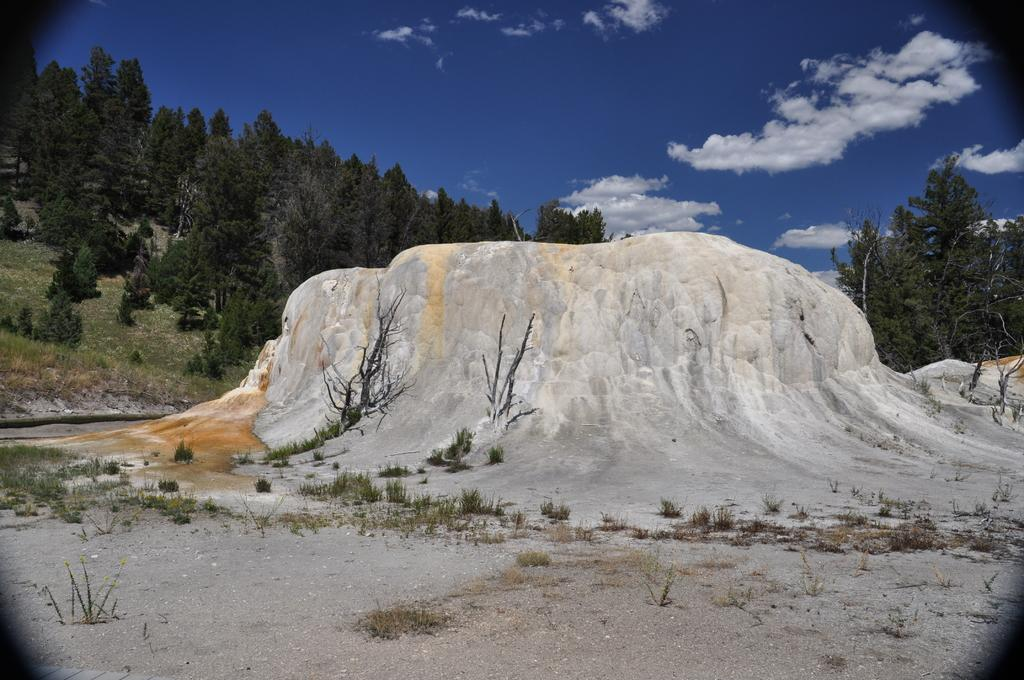What is the color of the mountain in the image? The mountain in the image is white. What type of vegetation can be seen in the image? There are green color trees in the image. What is the color of the sky in the image? The sky is blue in the image. What else can be seen in the sky besides the blue color? There are white color clouds in the image. How many books are stacked on the feet of the mountain in the image? There are no books or feet present in the image; it features a white mountain, green trees, a blue sky, and white clouds. Is there any indication of an attack happening in the image? There is no indication of an attack or any conflict in the image. 